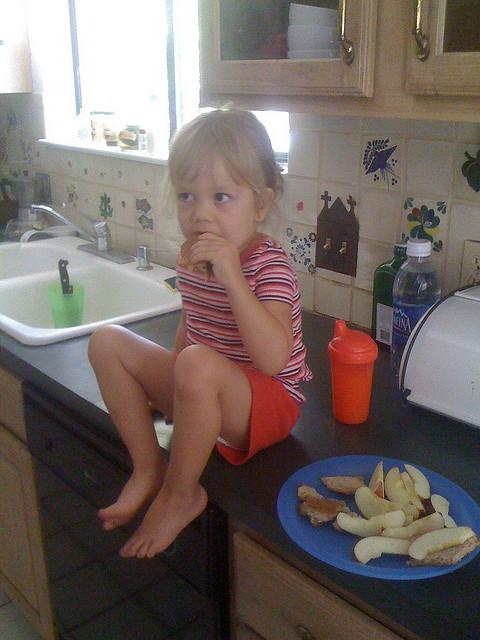What is a danger to the child? falling 